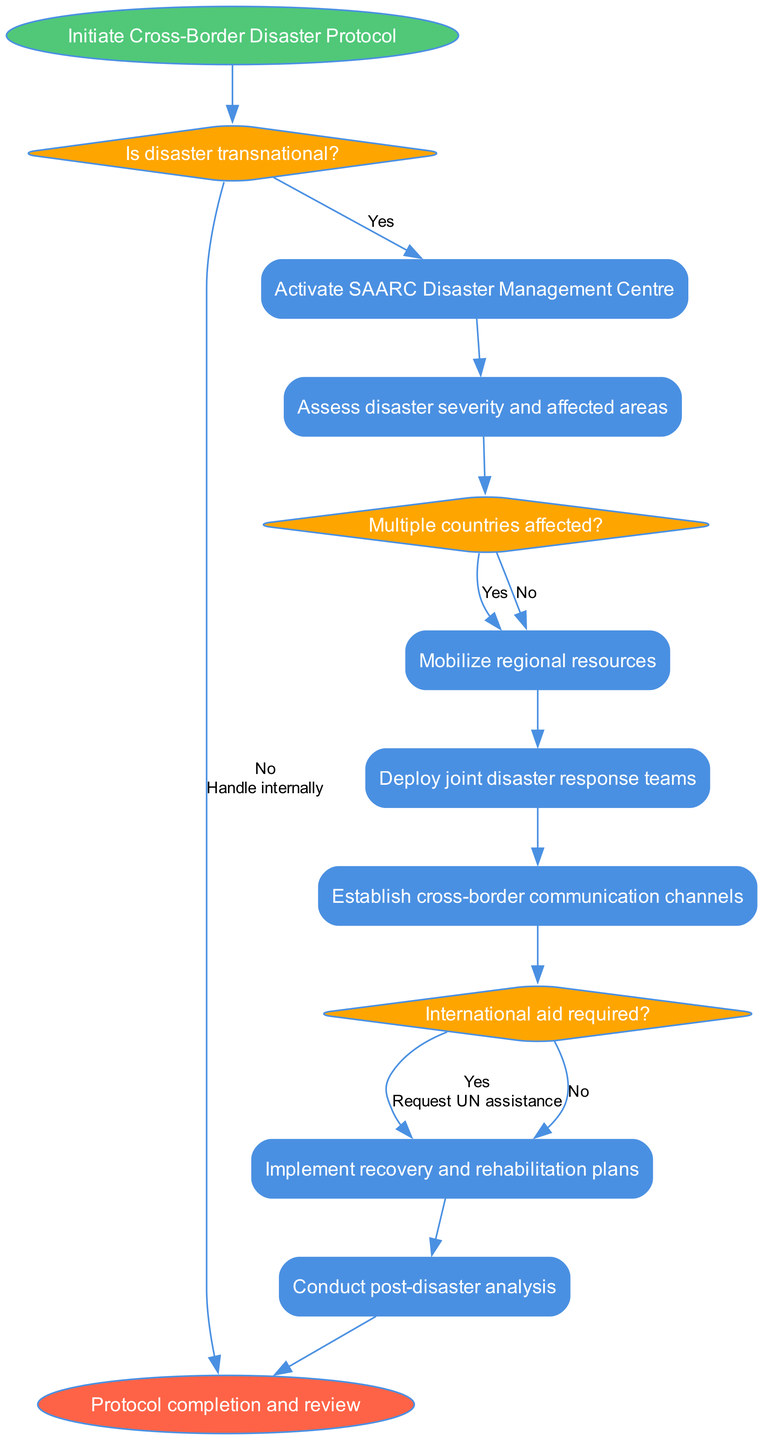What is the start node of the flowchart? The start node is labeled "Initiate Cross-Border Disaster Protocol," which indicates the beginning of the process described in the diagram.
Answer: Initiate Cross-Border Disaster Protocol What type of decision is represented as the first element in the diagram? The first decision in the diagram asks, "Is disaster transnational?" This determines whether the disaster requires cross-border protocols or not.
Answer: Decision How many process nodes are in the flowchart? The flowchart contains six process nodes, which represent the series of actions taken during the disaster management protocol.
Answer: Six What happens if the disaster is transnational? If the disaster is transnational, the flowchart indicates that the next step is to "Activate SAARC Disaster Management Centre." This leads to the subsequent assessment and coordination actions.
Answer: Activate SAARC Disaster Management Centre What is the outcome if multiple countries are affected? If multiple countries are affected, the flowchart directs to "Coordinate with affected nations," emphasizing the need for international collaboration in disaster response efforts.
Answer: Coordinate with affected nations How does the protocol handle the need for international aid? If international aid is needed, the flowchart specifies to "Request UN assistance," indicating a formal appeal for aid from global bodies to support the disaster response.
Answer: Request UN assistance Which node follows "Establish cross-border communication channels"? The flowchart progresses to the decision node asking, "International aid required?" after establishing communication channels, which is critical for effective coordination in disaster scenarios.
Answer: International aid required What is the final outcome of the flowchart? The final outcome, indicated at the end of the flowchart, is "Protocol completion and review," meaning the entire process concludes with an evaluation of the actions taken.
Answer: Protocol completion and review 